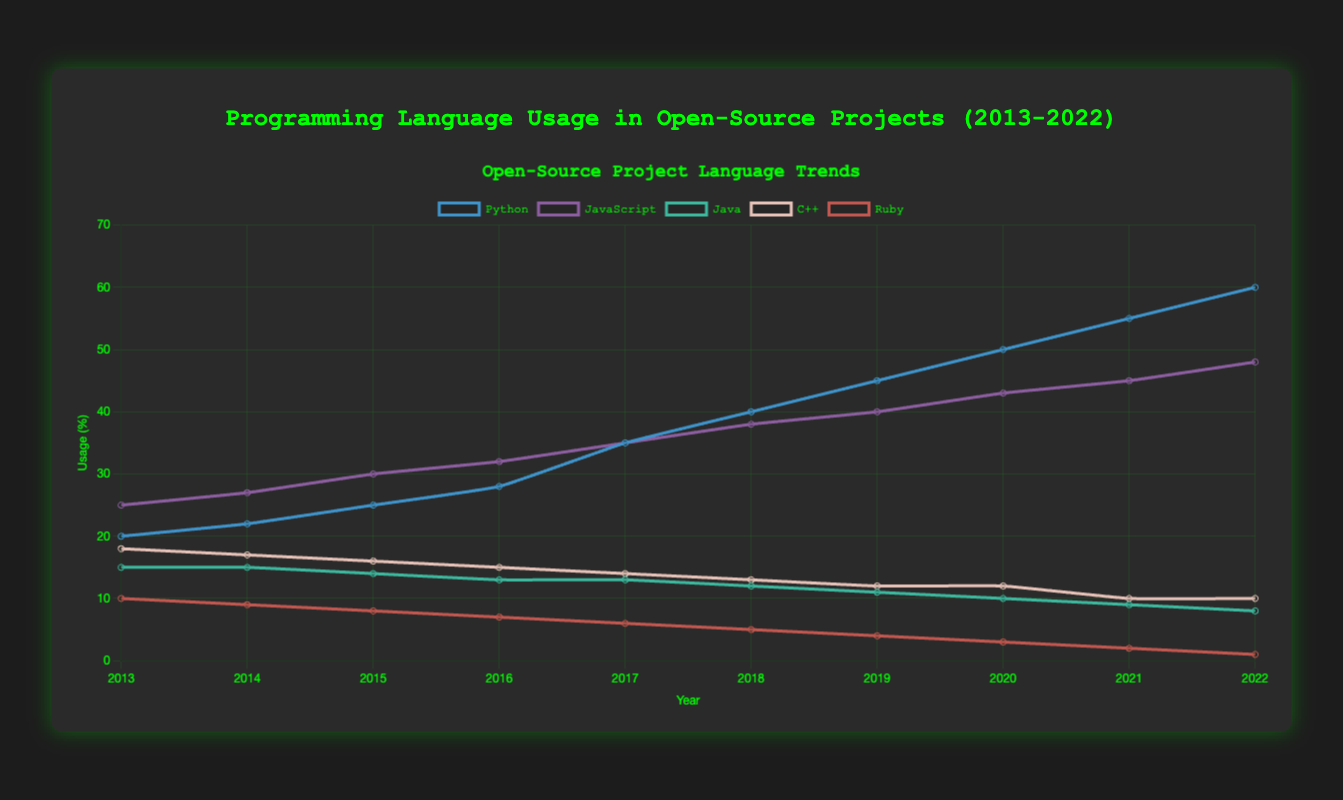What is the overall trend of Python usage from 2013 to 2022? The usage of Python has consistently increased every year from 20% in 2013 to 60% in 2022, showing a strong upward trend.
Answer: Increasing Which language had the highest usage in 2013? In 2013, JavaScript had the highest usage at 25%.
Answer: JavaScript How does the usage of Ruby in 2022 compare to its usage in 2013? Ruby's usage decreased from 10% in 2013 to 1% in 2022.
Answer: Decreased What was the lowest usage percentage of Java during the last 10 years? The lowest usage percentage of Java was 8% in 2022.
Answer: 8% Between 2021 and 2022, which language had the most significant increase in usage? Python had the most significant increase in usage, going from 55% in 2021 to 60% in 2022, an increase of 5%.
Answer: Python Compare the trend of JavaScript and Python from 2013 to 2022. Both JavaScript and Python showed an upward trend, but Python's increase was more dramatic, surging from 20% to 60%, whereas JavaScript increased from 25% to 48%.
Answer: Python increased more What is the difference in usage between Python and C++ in 2022? In 2022, Python's usage was 60% while C++'s was 10%, making the difference 50%.
Answer: 50% Which year did Python surpass JavaScript in usage? Python surpassed JavaScript in 2017, with both languages at 35%. From 2018 onward, Python consistently had higher usage.
Answer: 2017 What is the sum of the usage percentages of Python and JavaScript in 2015? In 2015, Python's usage was 25% and JavaScript's was 30%. The sum is 25% + 30% = 55%.
Answer: 55% Calculate the average annual growth in Python usage over the 10-year period. The total increase in Python usage from 2013 (20%) to 2022 (60%) is 40%. Over 10 years, the average annual growth is 40% / 10 = 4% per year.
Answer: 4% per year 